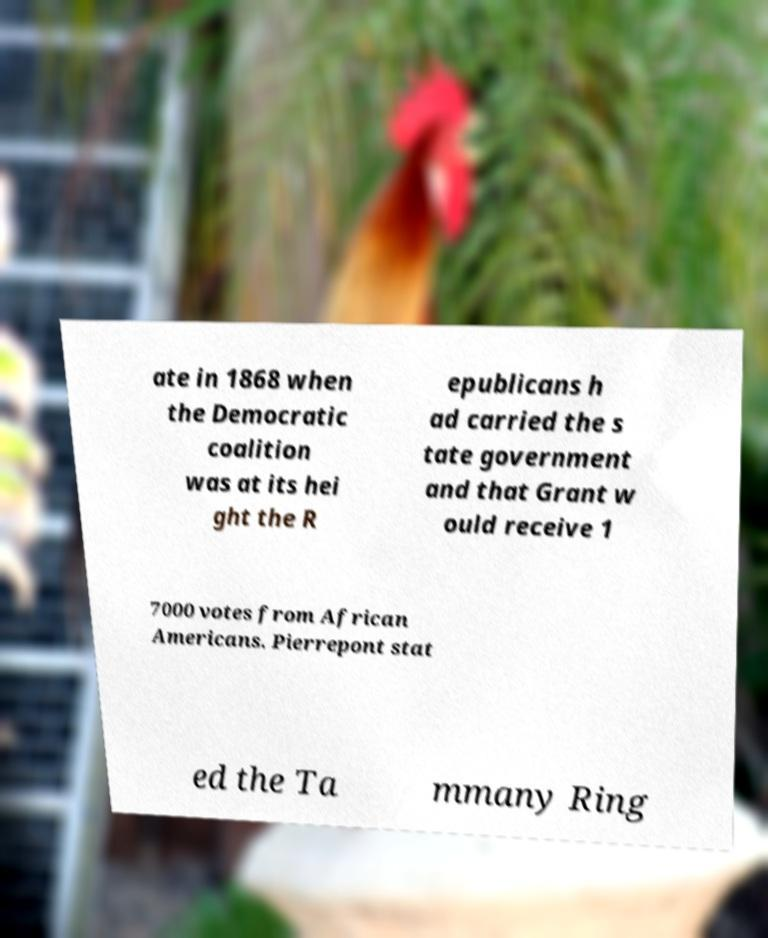What messages or text are displayed in this image? I need them in a readable, typed format. ate in 1868 when the Democratic coalition was at its hei ght the R epublicans h ad carried the s tate government and that Grant w ould receive 1 7000 votes from African Americans. Pierrepont stat ed the Ta mmany Ring 